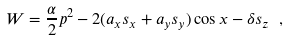<formula> <loc_0><loc_0><loc_500><loc_500>W = \frac { \alpha } { 2 } p ^ { 2 } - 2 ( a _ { x } s _ { x } + a _ { y } s _ { y } ) \cos x - \delta s _ { z } \ ,</formula> 